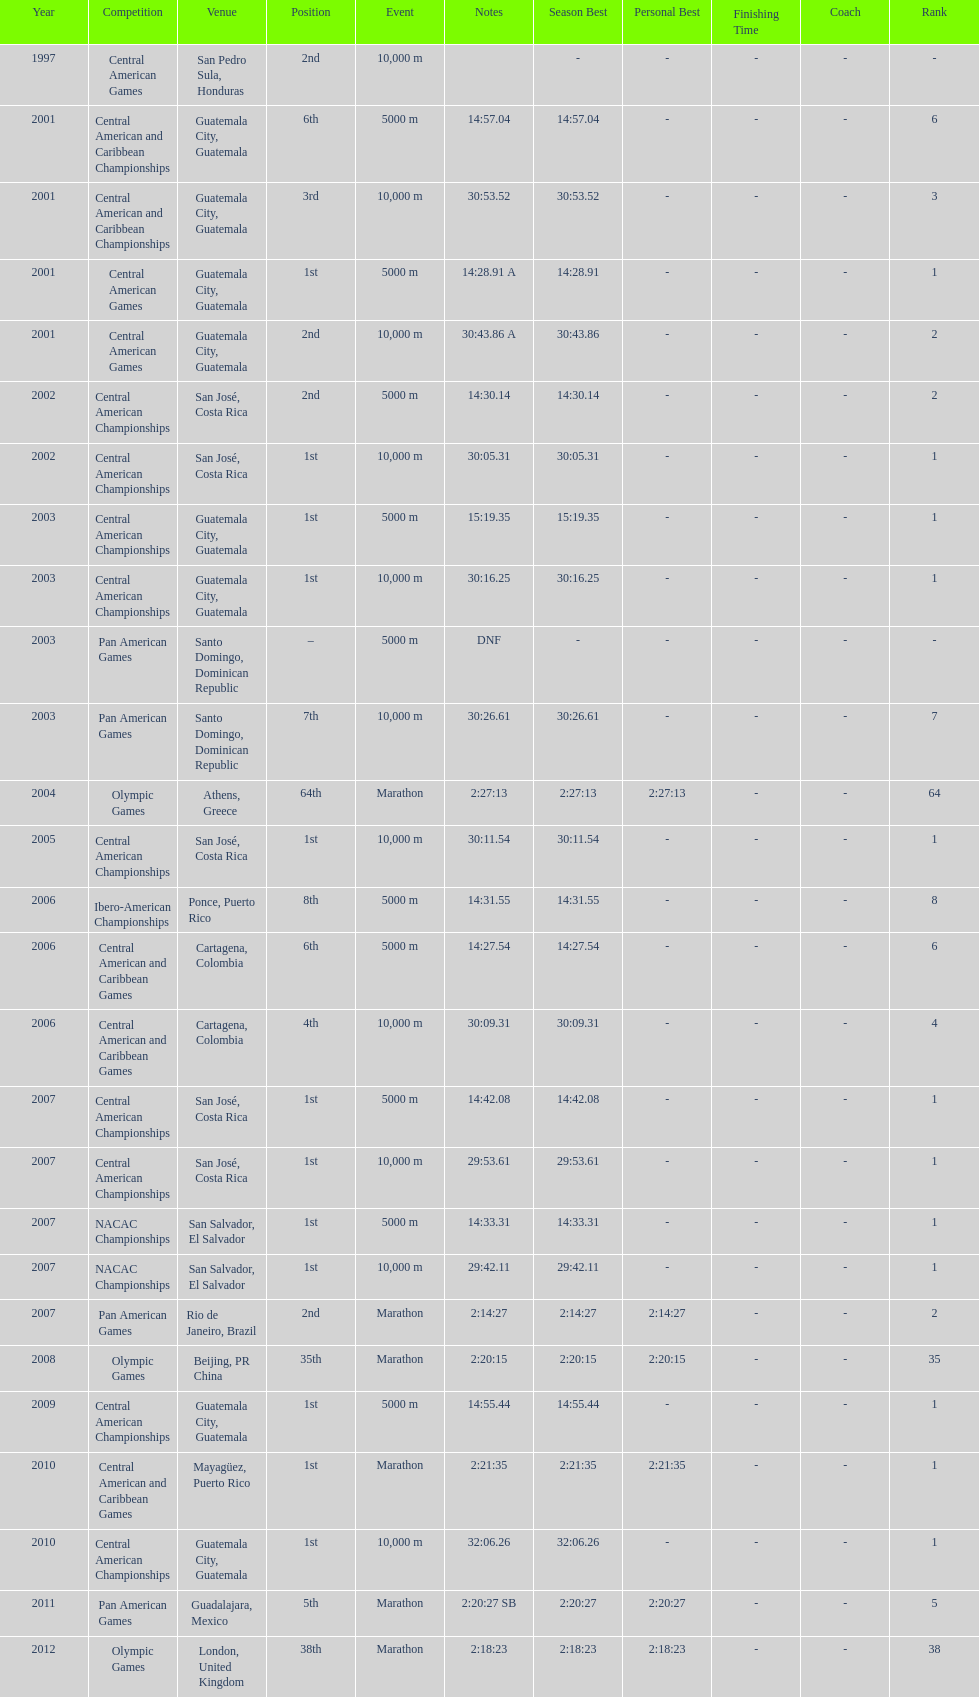Which of each game in 2007 was in the 2nd position? Pan American Games. 